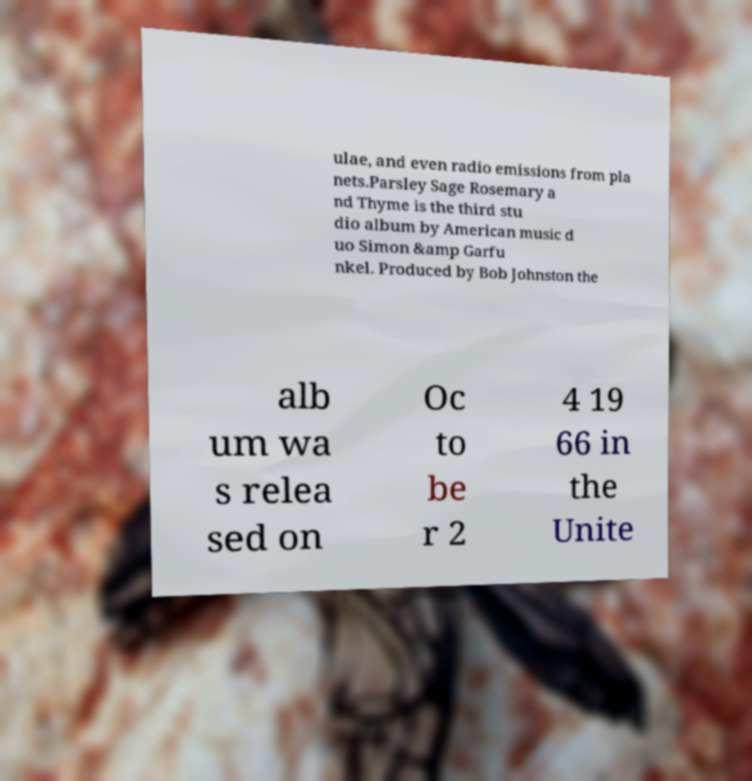For documentation purposes, I need the text within this image transcribed. Could you provide that? ulae, and even radio emissions from pla nets.Parsley Sage Rosemary a nd Thyme is the third stu dio album by American music d uo Simon &amp Garfu nkel. Produced by Bob Johnston the alb um wa s relea sed on Oc to be r 2 4 19 66 in the Unite 